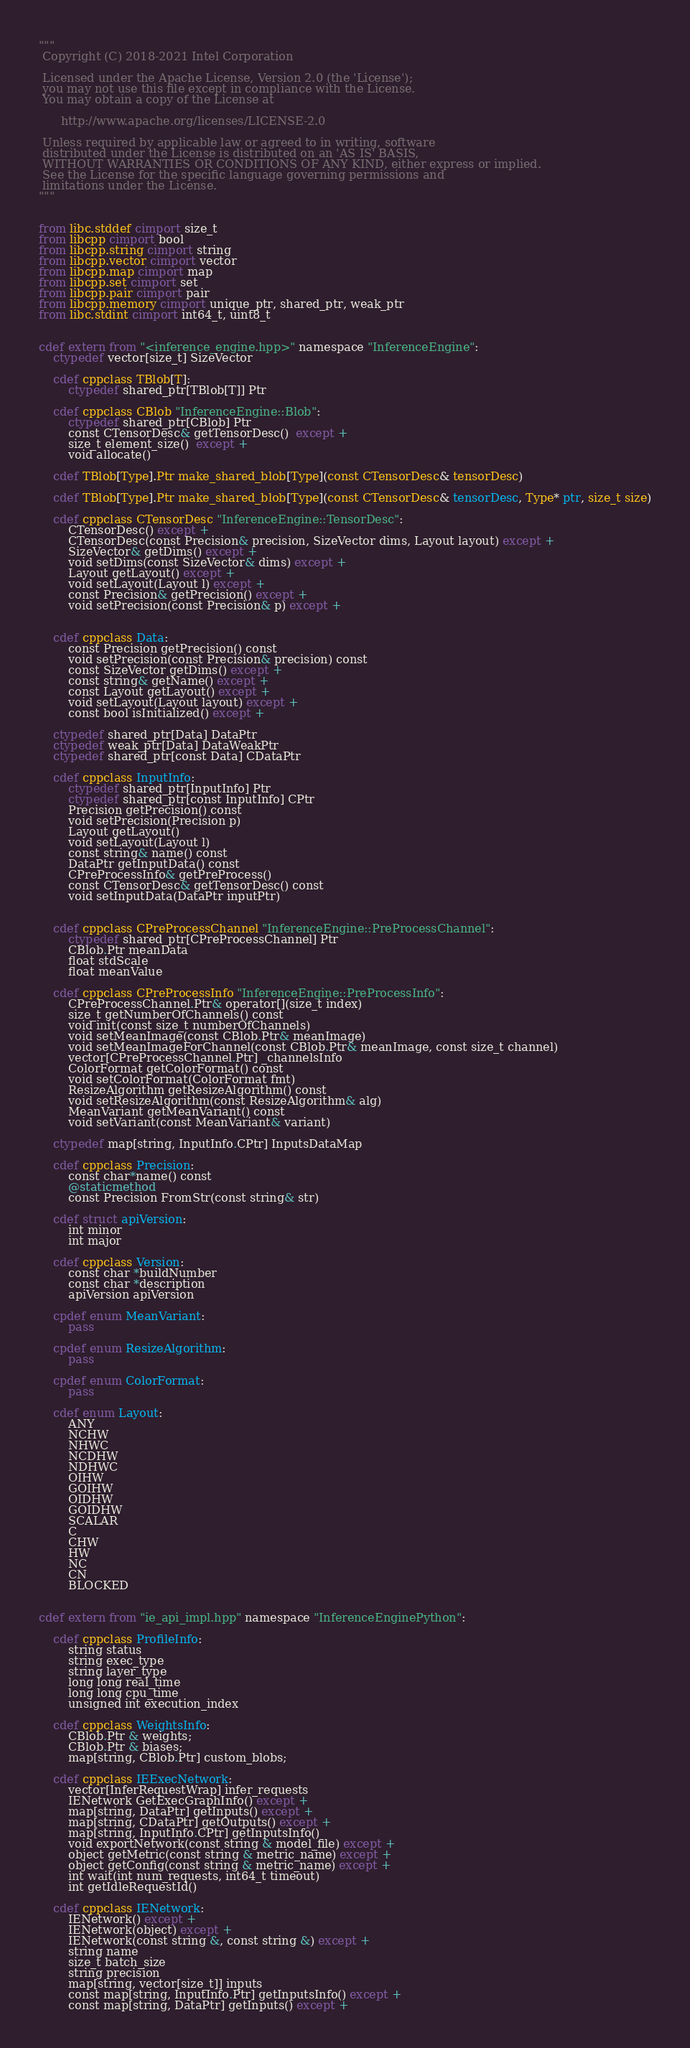<code> <loc_0><loc_0><loc_500><loc_500><_Cython_>"""
 Copyright (C) 2018-2021 Intel Corporation

 Licensed under the Apache License, Version 2.0 (the 'License');
 you may not use this file except in compliance with the License.
 You may obtain a copy of the License at

      http://www.apache.org/licenses/LICENSE-2.0

 Unless required by applicable law or agreed to in writing, software
 distributed under the License is distributed on an 'AS IS' BASIS,
 WITHOUT WARRANTIES OR CONDITIONS OF ANY KIND, either express or implied.
 See the License for the specific language governing permissions and
 limitations under the License.
"""


from libc.stddef cimport size_t
from libcpp cimport bool
from libcpp.string cimport string
from libcpp.vector cimport vector
from libcpp.map cimport map
from libcpp.set cimport set
from libcpp.pair cimport pair
from libcpp.memory cimport unique_ptr, shared_ptr, weak_ptr
from libc.stdint cimport int64_t, uint8_t


cdef extern from "<inference_engine.hpp>" namespace "InferenceEngine":
    ctypedef vector[size_t] SizeVector

    cdef cppclass TBlob[T]:
        ctypedef shared_ptr[TBlob[T]] Ptr

    cdef cppclass CBlob "InferenceEngine::Blob":
        ctypedef shared_ptr[CBlob] Ptr
        const CTensorDesc& getTensorDesc()  except +
        size_t element_size()  except +
        void allocate()

    cdef TBlob[Type].Ptr make_shared_blob[Type](const CTensorDesc& tensorDesc)

    cdef TBlob[Type].Ptr make_shared_blob[Type](const CTensorDesc& tensorDesc, Type* ptr, size_t size)

    cdef cppclass CTensorDesc "InferenceEngine::TensorDesc":
        CTensorDesc() except +
        CTensorDesc(const Precision& precision, SizeVector dims, Layout layout) except +
        SizeVector& getDims() except +
        void setDims(const SizeVector& dims) except +
        Layout getLayout() except +
        void setLayout(Layout l) except +
        const Precision& getPrecision() except +
        void setPrecision(const Precision& p) except +


    cdef cppclass Data:
        const Precision getPrecision() const
        void setPrecision(const Precision& precision) const
        const SizeVector getDims() except +
        const string& getName() except +
        const Layout getLayout() except +
        void setLayout(Layout layout) except +
        const bool isInitialized() except +

    ctypedef shared_ptr[Data] DataPtr
    ctypedef weak_ptr[Data] DataWeakPtr
    ctypedef shared_ptr[const Data] CDataPtr

    cdef cppclass InputInfo:
        ctypedef shared_ptr[InputInfo] Ptr
        ctypedef shared_ptr[const InputInfo] CPtr
        Precision getPrecision() const
        void setPrecision(Precision p)
        Layout getLayout()
        void setLayout(Layout l)
        const string& name() const
        DataPtr getInputData() const
        CPreProcessInfo& getPreProcess()
        const CTensorDesc& getTensorDesc() const
        void setInputData(DataPtr inputPtr)


    cdef cppclass CPreProcessChannel "InferenceEngine::PreProcessChannel":
        ctypedef shared_ptr[CPreProcessChannel] Ptr
        CBlob.Ptr meanData
        float stdScale
        float meanValue

    cdef cppclass CPreProcessInfo "InferenceEngine::PreProcessInfo":
        CPreProcessChannel.Ptr& operator[](size_t index)
        size_t getNumberOfChannels() const
        void init(const size_t numberOfChannels)
        void setMeanImage(const CBlob.Ptr& meanImage)
        void setMeanImageForChannel(const CBlob.Ptr& meanImage, const size_t channel)
        vector[CPreProcessChannel.Ptr] _channelsInfo
        ColorFormat getColorFormat() const
        void setColorFormat(ColorFormat fmt)
        ResizeAlgorithm getResizeAlgorithm() const
        void setResizeAlgorithm(const ResizeAlgorithm& alg)
        MeanVariant getMeanVariant() const
        void setVariant(const MeanVariant& variant)

    ctypedef map[string, InputInfo.CPtr] InputsDataMap

    cdef cppclass Precision:
        const char*name() const
        @staticmethod
        const Precision FromStr(const string& str)

    cdef struct apiVersion:
        int minor
        int major

    cdef cppclass Version:
        const char *buildNumber
        const char *description
        apiVersion apiVersion

    cpdef enum MeanVariant:
        pass

    cpdef enum ResizeAlgorithm:
        pass

    cpdef enum ColorFormat:
        pass

    cdef enum Layout:
        ANY
        NCHW
        NHWC
        NCDHW
        NDHWC
        OIHW
        GOIHW
        OIDHW
        GOIDHW
        SCALAR
        C
        CHW
        HW
        NC
        CN
        BLOCKED


cdef extern from "ie_api_impl.hpp" namespace "InferenceEnginePython":

    cdef cppclass ProfileInfo:
        string status
        string exec_type
        string layer_type
        long long real_time
        long long cpu_time
        unsigned int execution_index

    cdef cppclass WeightsInfo:
        CBlob.Ptr & weights;
        CBlob.Ptr & biases;
        map[string, CBlob.Ptr] custom_blobs;

    cdef cppclass IEExecNetwork:
        vector[InferRequestWrap] infer_requests
        IENetwork GetExecGraphInfo() except +
        map[string, DataPtr] getInputs() except +
        map[string, CDataPtr] getOutputs() except +
        map[string, InputInfo.CPtr] getInputsInfo()
        void exportNetwork(const string & model_file) except +
        object getMetric(const string & metric_name) except +
        object getConfig(const string & metric_name) except +
        int wait(int num_requests, int64_t timeout)
        int getIdleRequestId()

    cdef cppclass IENetwork:
        IENetwork() except +
        IENetwork(object) except +
        IENetwork(const string &, const string &) except +
        string name
        size_t batch_size
        string precision
        map[string, vector[size_t]] inputs
        const map[string, InputInfo.Ptr] getInputsInfo() except +
        const map[string, DataPtr] getInputs() except +</code> 